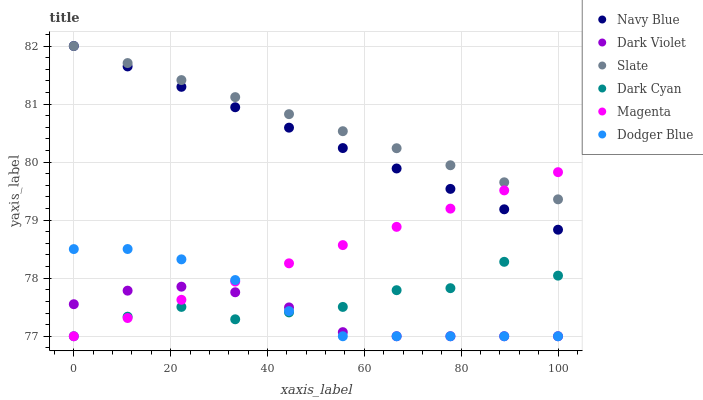Does Dark Violet have the minimum area under the curve?
Answer yes or no. Yes. Does Slate have the maximum area under the curve?
Answer yes or no. Yes. Does Slate have the minimum area under the curve?
Answer yes or no. No. Does Dark Violet have the maximum area under the curve?
Answer yes or no. No. Is Navy Blue the smoothest?
Answer yes or no. Yes. Is Dark Cyan the roughest?
Answer yes or no. Yes. Is Slate the smoothest?
Answer yes or no. No. Is Slate the roughest?
Answer yes or no. No. Does Dark Violet have the lowest value?
Answer yes or no. Yes. Does Slate have the lowest value?
Answer yes or no. No. Does Slate have the highest value?
Answer yes or no. Yes. Does Dark Violet have the highest value?
Answer yes or no. No. Is Dark Cyan less than Navy Blue?
Answer yes or no. Yes. Is Navy Blue greater than Dark Violet?
Answer yes or no. Yes. Does Dark Violet intersect Magenta?
Answer yes or no. Yes. Is Dark Violet less than Magenta?
Answer yes or no. No. Is Dark Violet greater than Magenta?
Answer yes or no. No. Does Dark Cyan intersect Navy Blue?
Answer yes or no. No. 